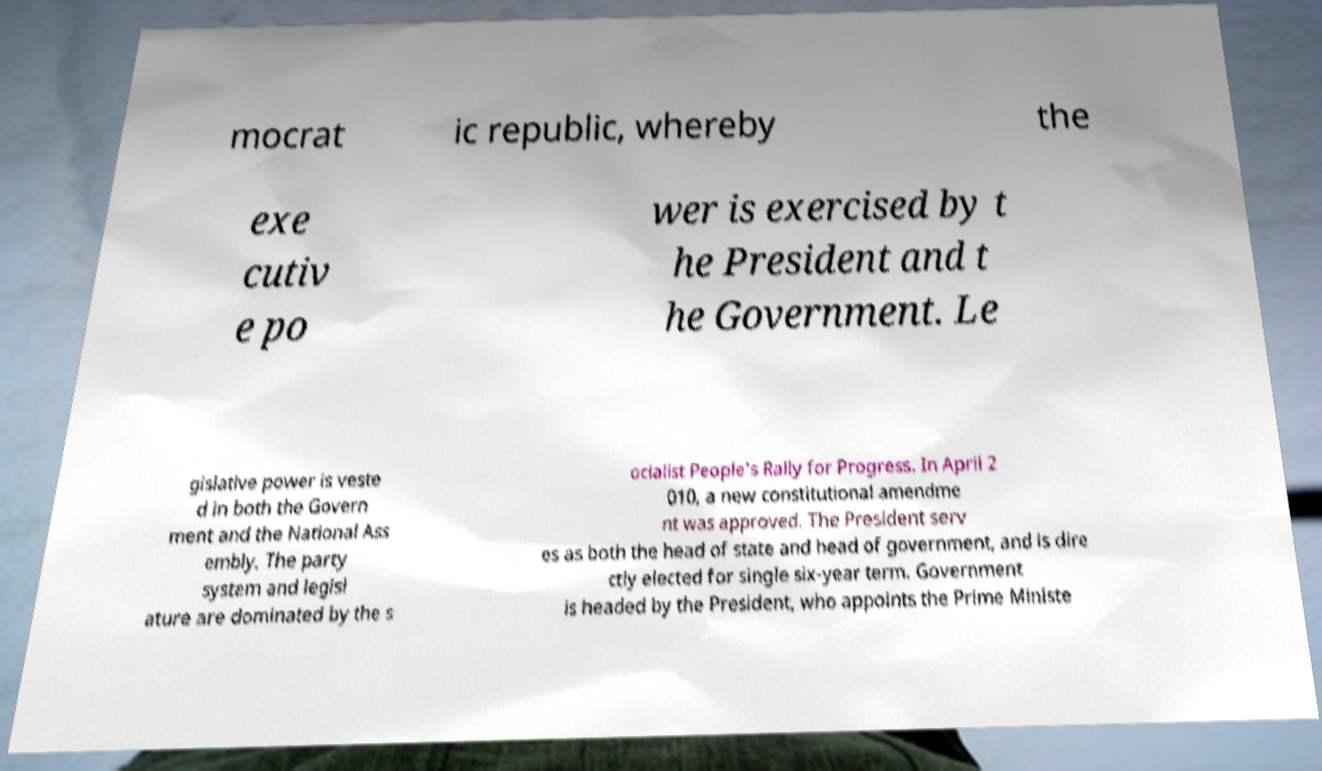Please read and relay the text visible in this image. What does it say? mocrat ic republic, whereby the exe cutiv e po wer is exercised by t he President and t he Government. Le gislative power is veste d in both the Govern ment and the National Ass embly. The party system and legisl ature are dominated by the s ocialist People's Rally for Progress. In April 2 010, a new constitutional amendme nt was approved. The President serv es as both the head of state and head of government, and is dire ctly elected for single six-year term. Government is headed by the President, who appoints the Prime Ministe 